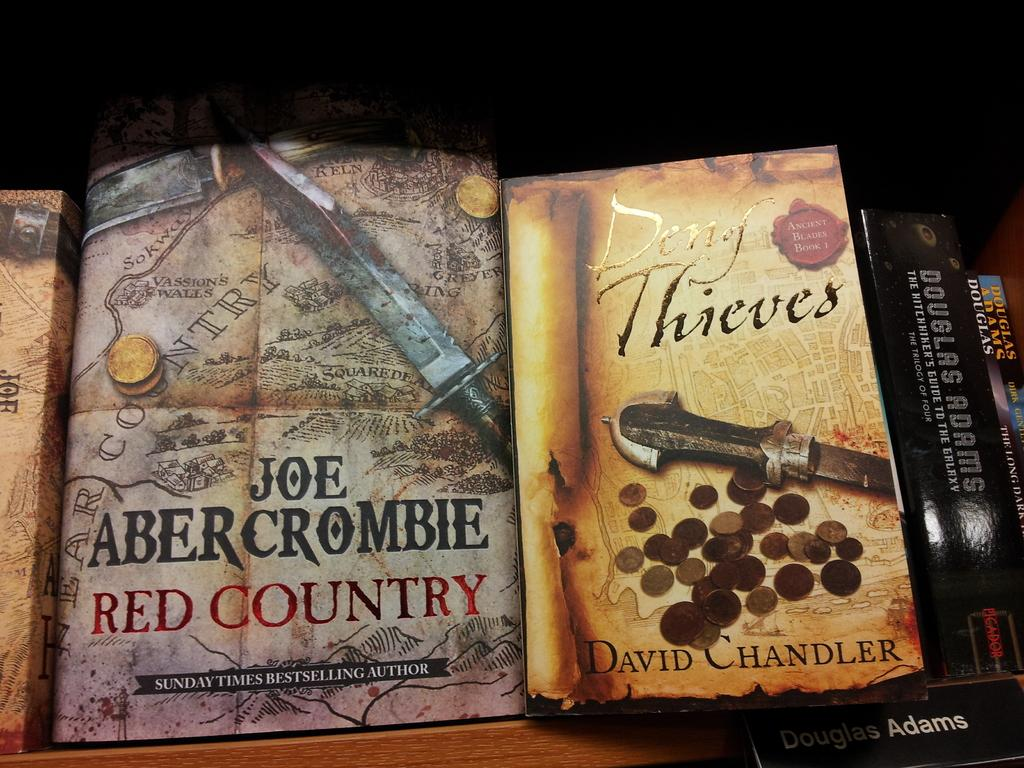<image>
Render a clear and concise summary of the photo. Two books next to each other and the right one is called Den of Thieves 